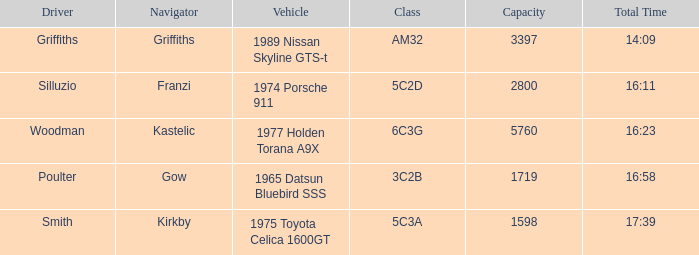Help me parse the entirety of this table. {'header': ['Driver', 'Navigator', 'Vehicle', 'Class', 'Capacity', 'Total Time'], 'rows': [['Griffiths', 'Griffiths', '1989 Nissan Skyline GTS-t', 'AM32', '3397', '14:09'], ['Silluzio', 'Franzi', '1974 Porsche 911', '5C2D', '2800', '16:11'], ['Woodman', 'Kastelic', '1977 Holden Torana A9X', '6C3G', '5760', '16:23'], ['Poulter', 'Gow', '1965 Datsun Bluebird SSS', '3C2B', '1719', '16:58'], ['Smith', 'Kirkby', '1975 Toyota Celica 1600GT', '5C3A', '1598', '17:39']]} What driver had a total time of 16:58? Poulter. 